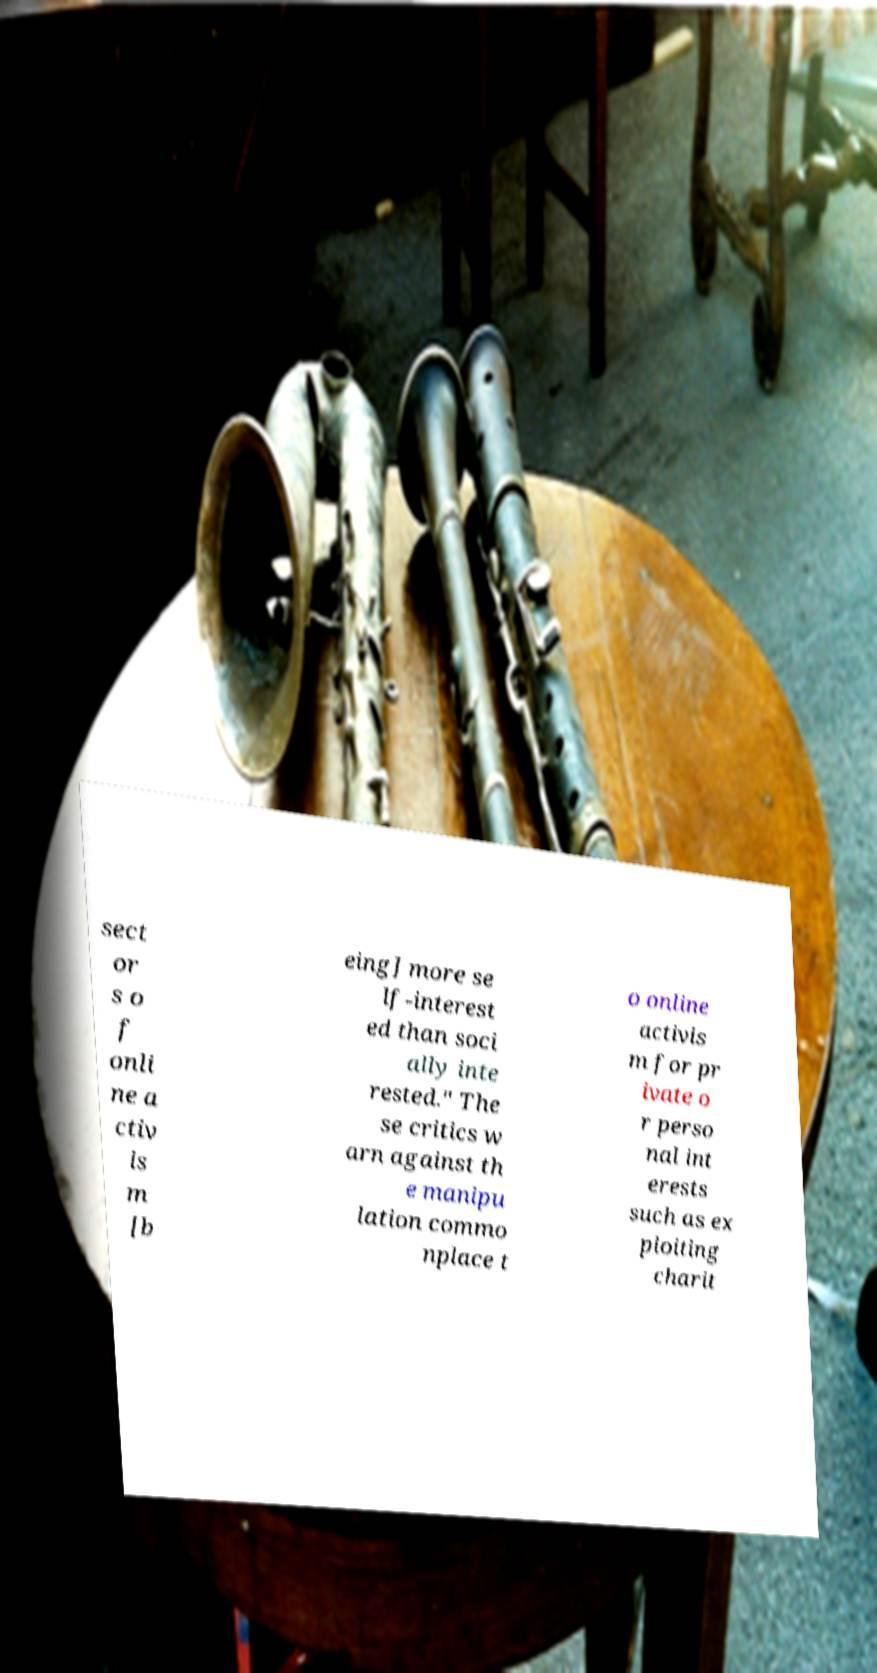Can you read and provide the text displayed in the image?This photo seems to have some interesting text. Can you extract and type it out for me? sect or s o f onli ne a ctiv is m [b eing] more se lf-interest ed than soci ally inte rested." The se critics w arn against th e manipu lation commo nplace t o online activis m for pr ivate o r perso nal int erests such as ex ploiting charit 